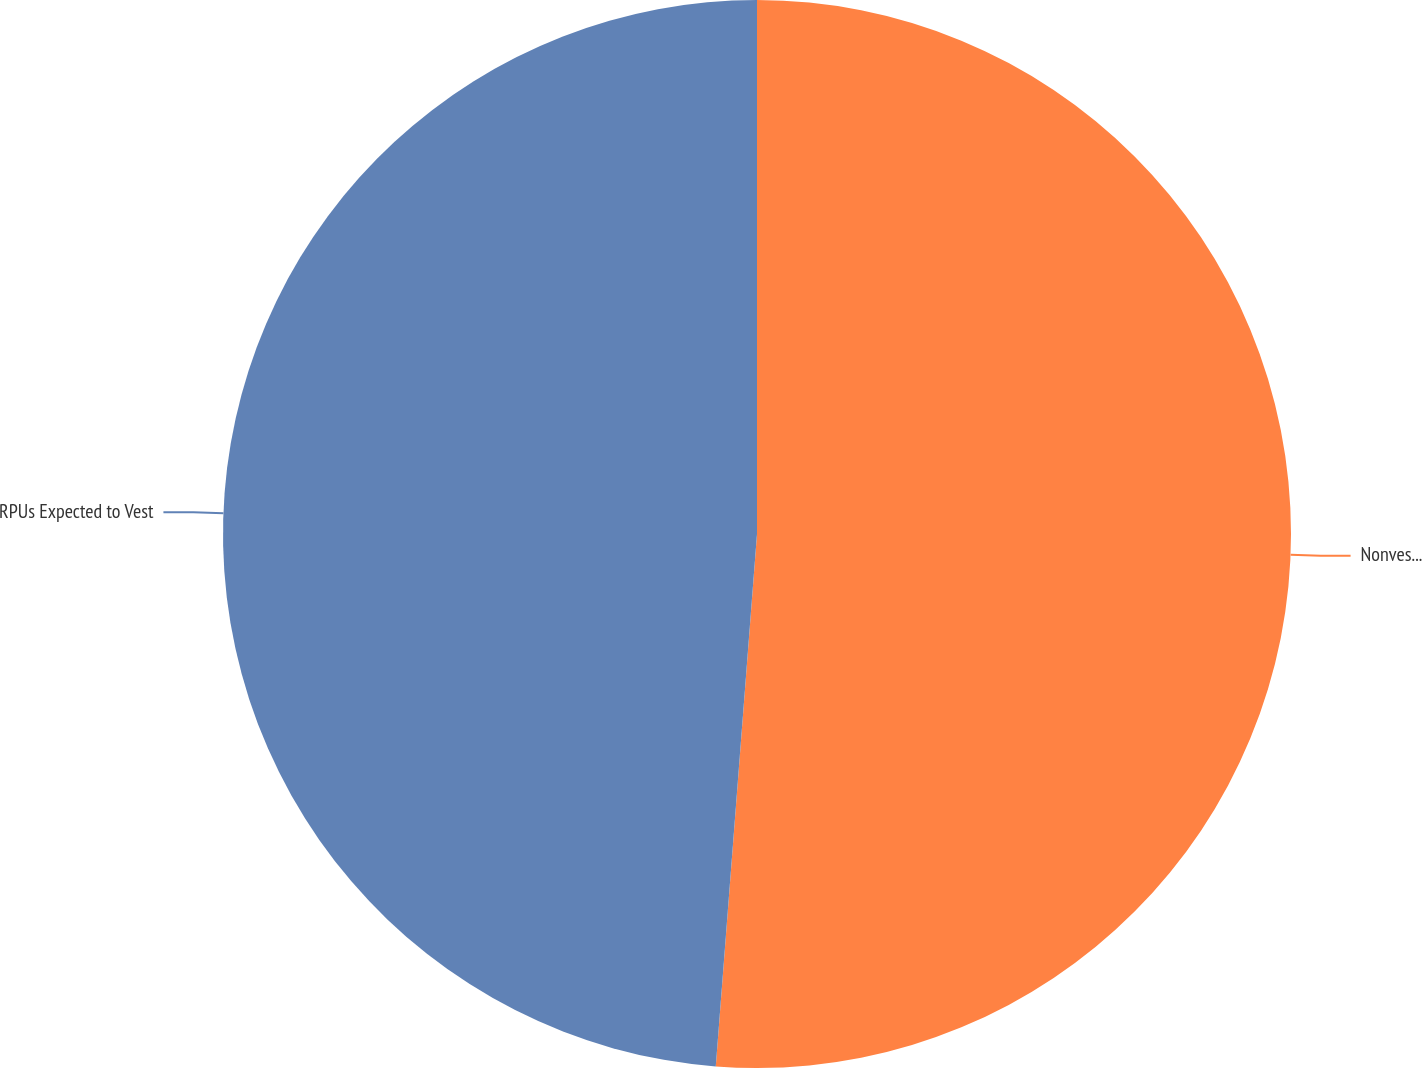<chart> <loc_0><loc_0><loc_500><loc_500><pie_chart><fcel>Nonvested at December 31 2009<fcel>RPUs Expected to Vest<nl><fcel>51.23%<fcel>48.77%<nl></chart> 